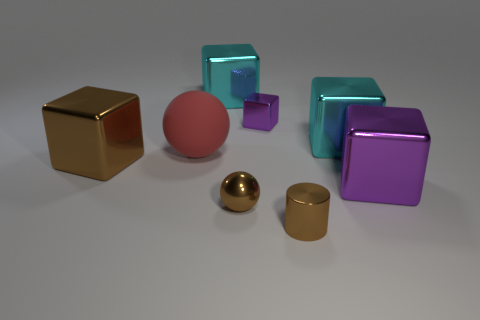Subtract all cyan blocks. How many were subtracted if there are1cyan blocks left? 1 Add 1 red balls. How many objects exist? 9 Subtract all tiny metal blocks. How many blocks are left? 4 Subtract all cubes. How many objects are left? 3 Subtract 1 cubes. How many cubes are left? 4 Subtract all red spheres. Subtract all red cylinders. How many spheres are left? 1 Subtract all brown balls. How many purple cubes are left? 2 Subtract all big metal blocks. Subtract all tiny purple metallic objects. How many objects are left? 3 Add 6 large cyan metal things. How many large cyan metal things are left? 8 Add 6 large metal cubes. How many large metal cubes exist? 10 